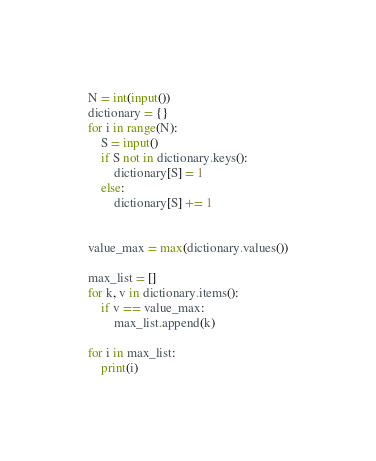<code> <loc_0><loc_0><loc_500><loc_500><_Python_>N = int(input())
dictionary = {}
for i in range(N):
    S = input()
    if S not in dictionary.keys():
        dictionary[S] = 1
    else:
        dictionary[S] += 1


value_max = max(dictionary.values())

max_list = []
for k, v in dictionary.items():
    if v == value_max:
        max_list.append(k)

for i in max_list:
    print(i)</code> 